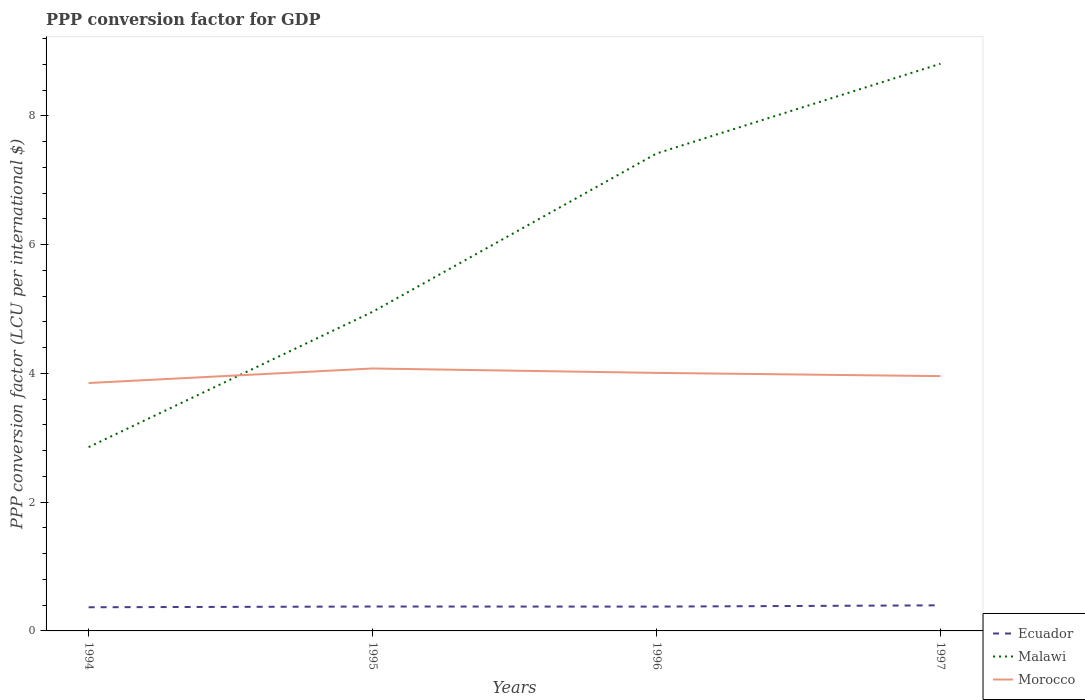Does the line corresponding to Morocco intersect with the line corresponding to Ecuador?
Offer a terse response. No. Is the number of lines equal to the number of legend labels?
Your answer should be very brief. Yes. Across all years, what is the maximum PPP conversion factor for GDP in Ecuador?
Your answer should be compact. 0.37. In which year was the PPP conversion factor for GDP in Morocco maximum?
Offer a terse response. 1994. What is the total PPP conversion factor for GDP in Ecuador in the graph?
Your answer should be compact. 0. What is the difference between the highest and the second highest PPP conversion factor for GDP in Morocco?
Provide a short and direct response. 0.23. What is the difference between the highest and the lowest PPP conversion factor for GDP in Ecuador?
Give a very brief answer. 1. How many lines are there?
Your answer should be compact. 3. Does the graph contain any zero values?
Give a very brief answer. No. Where does the legend appear in the graph?
Keep it short and to the point. Bottom right. How many legend labels are there?
Offer a very short reply. 3. How are the legend labels stacked?
Make the answer very short. Vertical. What is the title of the graph?
Provide a succinct answer. PPP conversion factor for GDP. Does "Djibouti" appear as one of the legend labels in the graph?
Offer a terse response. No. What is the label or title of the X-axis?
Offer a very short reply. Years. What is the label or title of the Y-axis?
Offer a very short reply. PPP conversion factor (LCU per international $). What is the PPP conversion factor (LCU per international $) of Ecuador in 1994?
Offer a terse response. 0.37. What is the PPP conversion factor (LCU per international $) in Malawi in 1994?
Your response must be concise. 2.85. What is the PPP conversion factor (LCU per international $) of Morocco in 1994?
Your response must be concise. 3.85. What is the PPP conversion factor (LCU per international $) of Ecuador in 1995?
Provide a short and direct response. 0.38. What is the PPP conversion factor (LCU per international $) in Malawi in 1995?
Keep it short and to the point. 4.96. What is the PPP conversion factor (LCU per international $) of Morocco in 1995?
Provide a succinct answer. 4.08. What is the PPP conversion factor (LCU per international $) in Ecuador in 1996?
Your answer should be compact. 0.38. What is the PPP conversion factor (LCU per international $) in Malawi in 1996?
Give a very brief answer. 7.41. What is the PPP conversion factor (LCU per international $) of Morocco in 1996?
Keep it short and to the point. 4.01. What is the PPP conversion factor (LCU per international $) in Ecuador in 1997?
Give a very brief answer. 0.4. What is the PPP conversion factor (LCU per international $) in Malawi in 1997?
Provide a succinct answer. 8.81. What is the PPP conversion factor (LCU per international $) of Morocco in 1997?
Make the answer very short. 3.96. Across all years, what is the maximum PPP conversion factor (LCU per international $) of Ecuador?
Your answer should be very brief. 0.4. Across all years, what is the maximum PPP conversion factor (LCU per international $) of Malawi?
Provide a short and direct response. 8.81. Across all years, what is the maximum PPP conversion factor (LCU per international $) in Morocco?
Provide a succinct answer. 4.08. Across all years, what is the minimum PPP conversion factor (LCU per international $) in Ecuador?
Keep it short and to the point. 0.37. Across all years, what is the minimum PPP conversion factor (LCU per international $) in Malawi?
Make the answer very short. 2.85. Across all years, what is the minimum PPP conversion factor (LCU per international $) in Morocco?
Your answer should be very brief. 3.85. What is the total PPP conversion factor (LCU per international $) of Ecuador in the graph?
Provide a succinct answer. 1.52. What is the total PPP conversion factor (LCU per international $) in Malawi in the graph?
Ensure brevity in your answer.  24.03. What is the total PPP conversion factor (LCU per international $) of Morocco in the graph?
Offer a very short reply. 15.89. What is the difference between the PPP conversion factor (LCU per international $) of Ecuador in 1994 and that in 1995?
Ensure brevity in your answer.  -0.01. What is the difference between the PPP conversion factor (LCU per international $) of Malawi in 1994 and that in 1995?
Make the answer very short. -2.1. What is the difference between the PPP conversion factor (LCU per international $) in Morocco in 1994 and that in 1995?
Provide a short and direct response. -0.23. What is the difference between the PPP conversion factor (LCU per international $) of Ecuador in 1994 and that in 1996?
Provide a succinct answer. -0.01. What is the difference between the PPP conversion factor (LCU per international $) in Malawi in 1994 and that in 1996?
Your response must be concise. -4.56. What is the difference between the PPP conversion factor (LCU per international $) of Morocco in 1994 and that in 1996?
Keep it short and to the point. -0.16. What is the difference between the PPP conversion factor (LCU per international $) in Ecuador in 1994 and that in 1997?
Offer a very short reply. -0.03. What is the difference between the PPP conversion factor (LCU per international $) of Malawi in 1994 and that in 1997?
Give a very brief answer. -5.95. What is the difference between the PPP conversion factor (LCU per international $) of Morocco in 1994 and that in 1997?
Your answer should be compact. -0.11. What is the difference between the PPP conversion factor (LCU per international $) of Ecuador in 1995 and that in 1996?
Give a very brief answer. 0. What is the difference between the PPP conversion factor (LCU per international $) of Malawi in 1995 and that in 1996?
Provide a succinct answer. -2.46. What is the difference between the PPP conversion factor (LCU per international $) in Morocco in 1995 and that in 1996?
Your response must be concise. 0.07. What is the difference between the PPP conversion factor (LCU per international $) in Ecuador in 1995 and that in 1997?
Give a very brief answer. -0.02. What is the difference between the PPP conversion factor (LCU per international $) of Malawi in 1995 and that in 1997?
Offer a terse response. -3.85. What is the difference between the PPP conversion factor (LCU per international $) in Morocco in 1995 and that in 1997?
Provide a succinct answer. 0.12. What is the difference between the PPP conversion factor (LCU per international $) in Ecuador in 1996 and that in 1997?
Your answer should be compact. -0.02. What is the difference between the PPP conversion factor (LCU per international $) of Malawi in 1996 and that in 1997?
Offer a very short reply. -1.39. What is the difference between the PPP conversion factor (LCU per international $) of Ecuador in 1994 and the PPP conversion factor (LCU per international $) of Malawi in 1995?
Provide a short and direct response. -4.59. What is the difference between the PPP conversion factor (LCU per international $) in Ecuador in 1994 and the PPP conversion factor (LCU per international $) in Morocco in 1995?
Provide a short and direct response. -3.71. What is the difference between the PPP conversion factor (LCU per international $) in Malawi in 1994 and the PPP conversion factor (LCU per international $) in Morocco in 1995?
Give a very brief answer. -1.22. What is the difference between the PPP conversion factor (LCU per international $) in Ecuador in 1994 and the PPP conversion factor (LCU per international $) in Malawi in 1996?
Provide a short and direct response. -7.05. What is the difference between the PPP conversion factor (LCU per international $) of Ecuador in 1994 and the PPP conversion factor (LCU per international $) of Morocco in 1996?
Ensure brevity in your answer.  -3.64. What is the difference between the PPP conversion factor (LCU per international $) of Malawi in 1994 and the PPP conversion factor (LCU per international $) of Morocco in 1996?
Your answer should be compact. -1.15. What is the difference between the PPP conversion factor (LCU per international $) in Ecuador in 1994 and the PPP conversion factor (LCU per international $) in Malawi in 1997?
Your answer should be very brief. -8.44. What is the difference between the PPP conversion factor (LCU per international $) in Ecuador in 1994 and the PPP conversion factor (LCU per international $) in Morocco in 1997?
Make the answer very short. -3.59. What is the difference between the PPP conversion factor (LCU per international $) of Malawi in 1994 and the PPP conversion factor (LCU per international $) of Morocco in 1997?
Keep it short and to the point. -1.1. What is the difference between the PPP conversion factor (LCU per international $) of Ecuador in 1995 and the PPP conversion factor (LCU per international $) of Malawi in 1996?
Ensure brevity in your answer.  -7.04. What is the difference between the PPP conversion factor (LCU per international $) of Ecuador in 1995 and the PPP conversion factor (LCU per international $) of Morocco in 1996?
Provide a succinct answer. -3.63. What is the difference between the PPP conversion factor (LCU per international $) in Malawi in 1995 and the PPP conversion factor (LCU per international $) in Morocco in 1996?
Your answer should be compact. 0.95. What is the difference between the PPP conversion factor (LCU per international $) in Ecuador in 1995 and the PPP conversion factor (LCU per international $) in Malawi in 1997?
Provide a short and direct response. -8.43. What is the difference between the PPP conversion factor (LCU per international $) in Ecuador in 1995 and the PPP conversion factor (LCU per international $) in Morocco in 1997?
Give a very brief answer. -3.58. What is the difference between the PPP conversion factor (LCU per international $) in Ecuador in 1996 and the PPP conversion factor (LCU per international $) in Malawi in 1997?
Make the answer very short. -8.43. What is the difference between the PPP conversion factor (LCU per international $) in Ecuador in 1996 and the PPP conversion factor (LCU per international $) in Morocco in 1997?
Your answer should be compact. -3.58. What is the difference between the PPP conversion factor (LCU per international $) of Malawi in 1996 and the PPP conversion factor (LCU per international $) of Morocco in 1997?
Provide a succinct answer. 3.46. What is the average PPP conversion factor (LCU per international $) in Ecuador per year?
Your response must be concise. 0.38. What is the average PPP conversion factor (LCU per international $) in Malawi per year?
Provide a short and direct response. 6.01. What is the average PPP conversion factor (LCU per international $) of Morocco per year?
Give a very brief answer. 3.97. In the year 1994, what is the difference between the PPP conversion factor (LCU per international $) of Ecuador and PPP conversion factor (LCU per international $) of Malawi?
Provide a short and direct response. -2.49. In the year 1994, what is the difference between the PPP conversion factor (LCU per international $) of Ecuador and PPP conversion factor (LCU per international $) of Morocco?
Keep it short and to the point. -3.48. In the year 1994, what is the difference between the PPP conversion factor (LCU per international $) of Malawi and PPP conversion factor (LCU per international $) of Morocco?
Ensure brevity in your answer.  -1. In the year 1995, what is the difference between the PPP conversion factor (LCU per international $) of Ecuador and PPP conversion factor (LCU per international $) of Malawi?
Your answer should be very brief. -4.58. In the year 1995, what is the difference between the PPP conversion factor (LCU per international $) of Ecuador and PPP conversion factor (LCU per international $) of Morocco?
Make the answer very short. -3.7. In the year 1995, what is the difference between the PPP conversion factor (LCU per international $) of Malawi and PPP conversion factor (LCU per international $) of Morocco?
Ensure brevity in your answer.  0.88. In the year 1996, what is the difference between the PPP conversion factor (LCU per international $) in Ecuador and PPP conversion factor (LCU per international $) in Malawi?
Ensure brevity in your answer.  -7.04. In the year 1996, what is the difference between the PPP conversion factor (LCU per international $) in Ecuador and PPP conversion factor (LCU per international $) in Morocco?
Your answer should be compact. -3.63. In the year 1996, what is the difference between the PPP conversion factor (LCU per international $) of Malawi and PPP conversion factor (LCU per international $) of Morocco?
Offer a very short reply. 3.41. In the year 1997, what is the difference between the PPP conversion factor (LCU per international $) in Ecuador and PPP conversion factor (LCU per international $) in Malawi?
Make the answer very short. -8.41. In the year 1997, what is the difference between the PPP conversion factor (LCU per international $) of Ecuador and PPP conversion factor (LCU per international $) of Morocco?
Provide a short and direct response. -3.56. In the year 1997, what is the difference between the PPP conversion factor (LCU per international $) of Malawi and PPP conversion factor (LCU per international $) of Morocco?
Make the answer very short. 4.85. What is the ratio of the PPP conversion factor (LCU per international $) of Ecuador in 1994 to that in 1995?
Provide a short and direct response. 0.97. What is the ratio of the PPP conversion factor (LCU per international $) of Malawi in 1994 to that in 1995?
Provide a succinct answer. 0.58. What is the ratio of the PPP conversion factor (LCU per international $) in Morocco in 1994 to that in 1995?
Keep it short and to the point. 0.94. What is the ratio of the PPP conversion factor (LCU per international $) of Ecuador in 1994 to that in 1996?
Provide a short and direct response. 0.97. What is the ratio of the PPP conversion factor (LCU per international $) of Malawi in 1994 to that in 1996?
Your answer should be very brief. 0.39. What is the ratio of the PPP conversion factor (LCU per international $) of Morocco in 1994 to that in 1996?
Keep it short and to the point. 0.96. What is the ratio of the PPP conversion factor (LCU per international $) of Ecuador in 1994 to that in 1997?
Ensure brevity in your answer.  0.93. What is the ratio of the PPP conversion factor (LCU per international $) of Malawi in 1994 to that in 1997?
Offer a very short reply. 0.32. What is the ratio of the PPP conversion factor (LCU per international $) in Morocco in 1994 to that in 1997?
Your answer should be compact. 0.97. What is the ratio of the PPP conversion factor (LCU per international $) of Malawi in 1995 to that in 1996?
Your answer should be very brief. 0.67. What is the ratio of the PPP conversion factor (LCU per international $) in Morocco in 1995 to that in 1996?
Provide a short and direct response. 1.02. What is the ratio of the PPP conversion factor (LCU per international $) of Ecuador in 1995 to that in 1997?
Offer a terse response. 0.95. What is the ratio of the PPP conversion factor (LCU per international $) of Malawi in 1995 to that in 1997?
Provide a succinct answer. 0.56. What is the ratio of the PPP conversion factor (LCU per international $) in Morocco in 1995 to that in 1997?
Give a very brief answer. 1.03. What is the ratio of the PPP conversion factor (LCU per international $) in Ecuador in 1996 to that in 1997?
Make the answer very short. 0.95. What is the ratio of the PPP conversion factor (LCU per international $) in Malawi in 1996 to that in 1997?
Offer a terse response. 0.84. What is the ratio of the PPP conversion factor (LCU per international $) in Morocco in 1996 to that in 1997?
Offer a terse response. 1.01. What is the difference between the highest and the second highest PPP conversion factor (LCU per international $) of Ecuador?
Keep it short and to the point. 0.02. What is the difference between the highest and the second highest PPP conversion factor (LCU per international $) of Malawi?
Your answer should be compact. 1.39. What is the difference between the highest and the second highest PPP conversion factor (LCU per international $) of Morocco?
Keep it short and to the point. 0.07. What is the difference between the highest and the lowest PPP conversion factor (LCU per international $) of Ecuador?
Provide a short and direct response. 0.03. What is the difference between the highest and the lowest PPP conversion factor (LCU per international $) in Malawi?
Offer a very short reply. 5.95. What is the difference between the highest and the lowest PPP conversion factor (LCU per international $) of Morocco?
Your answer should be compact. 0.23. 